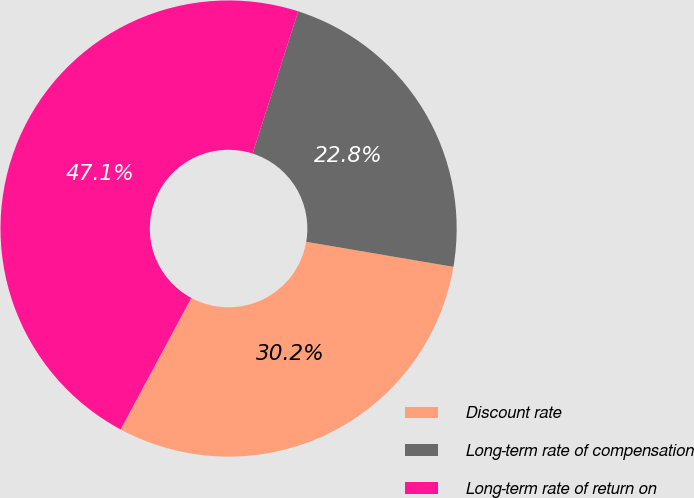Convert chart. <chart><loc_0><loc_0><loc_500><loc_500><pie_chart><fcel>Discount rate<fcel>Long-term rate of compensation<fcel>Long-term rate of return on<nl><fcel>30.16%<fcel>22.75%<fcel>47.09%<nl></chart> 